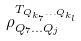<formula> <loc_0><loc_0><loc_500><loc_500>\rho _ { Q _ { 7 } \dots Q _ { j } } ^ { T _ { Q _ { k _ { 7 } } \dots Q _ { k _ { l } } } }</formula> 